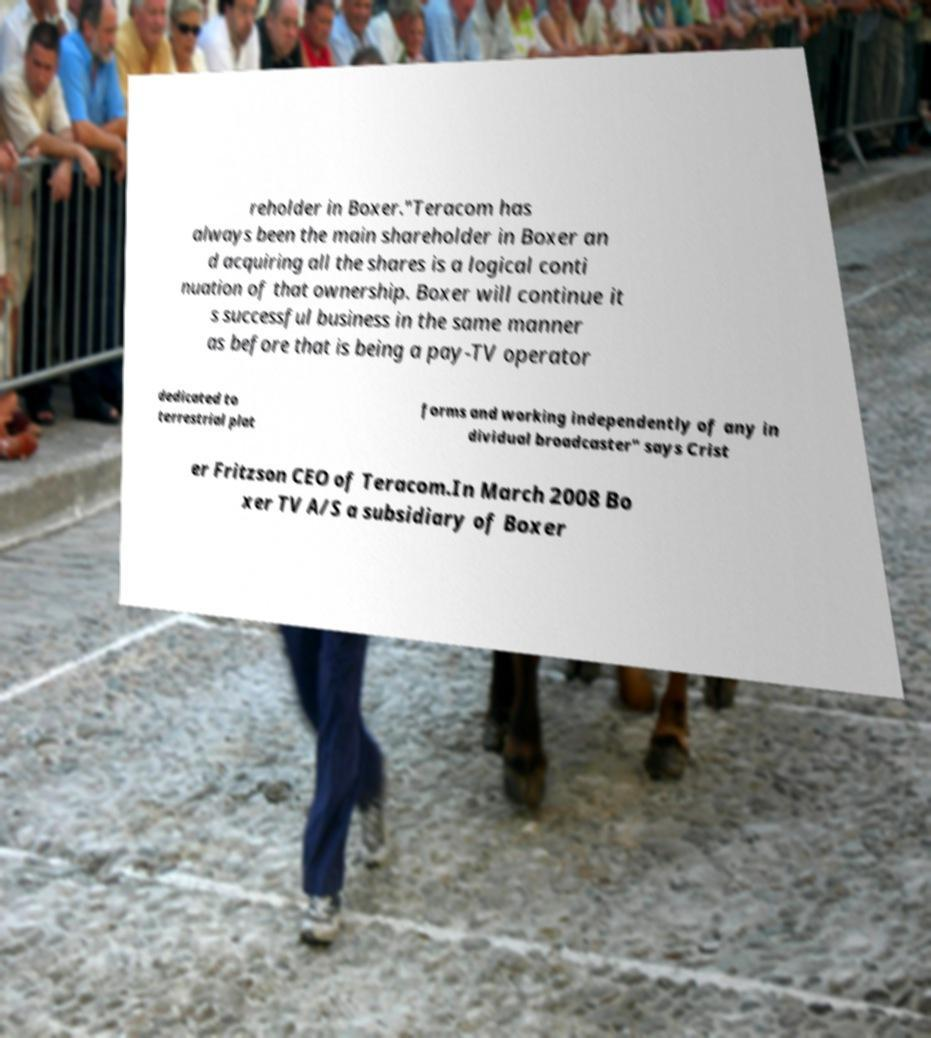Could you extract and type out the text from this image? reholder in Boxer."Teracom has always been the main shareholder in Boxer an d acquiring all the shares is a logical conti nuation of that ownership. Boxer will continue it s successful business in the same manner as before that is being a pay-TV operator dedicated to terrestrial plat forms and working independently of any in dividual broadcaster" says Crist er Fritzson CEO of Teracom.In March 2008 Bo xer TV A/S a subsidiary of Boxer 